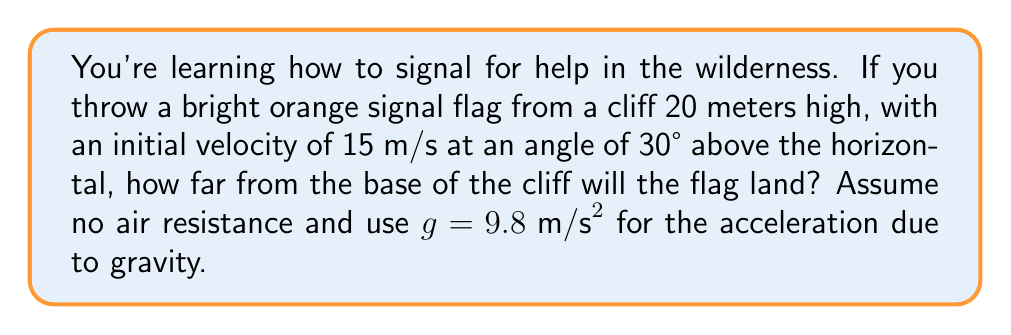Give your solution to this math problem. Let's approach this step-by-step:

1) First, we need to understand that this is a projectile motion problem. The trajectory of the flag will be parabolic.

2) We can split the motion into horizontal and vertical components:
   - Horizontal motion is constant velocity
   - Vertical motion is uniformly accelerated due to gravity

3) Let's identify our known variables:
   - Initial height, $h_0 = 20 \text{ m}$
   - Initial velocity, $v_0 = 15 \text{ m/s}$
   - Angle of projection, $\theta = 30°$
   - Acceleration due to gravity, $g = 9.8 \text{ m/s}^2$

4) We need to find the time of flight and then use that to calculate the horizontal distance.

5) For the vertical motion, we can use the equation:
   $$y = y_0 + v_0\sin(\theta)t - \frac{1}{2}gt^2$$

   Where $y = 0$ at landing, $y_0 = h_0 = 20 \text{ m}$, and $v_0\sin(\theta) = 15 \sin(30°) = 7.5 \text{ m/s}$

6) Substituting these values:
   $$0 = 20 + 7.5t - 4.9t^2$$

7) This is a quadratic equation. We can solve it using the quadratic formula:
   $$t = \frac{-b \pm \sqrt{b^2 - 4ac}}{2a}$$
   Where $a = -4.9$, $b = 7.5$, and $c = 20$

8) Solving this gives us two solutions: $t \approx 3.32 \text{ s}$ or $t \approx -1.21 \text{ s}$
   We take the positive solution as time can't be negative.

9) Now that we have the time of flight, we can calculate the horizontal distance using:
   $$x = v_0\cos(\theta)t$$

10) $v_0\cos(\theta) = 15 \cos(30°) = 15 \cdot \frac{\sqrt{3}}{2} \approx 12.99 \text{ m/s}$

11) Therefore, the horizontal distance is:
    $$x = 12.99 \cdot 3.32 \approx 43.13 \text{ m}$$
Answer: The flag will land approximately 43.13 meters from the base of the cliff. 